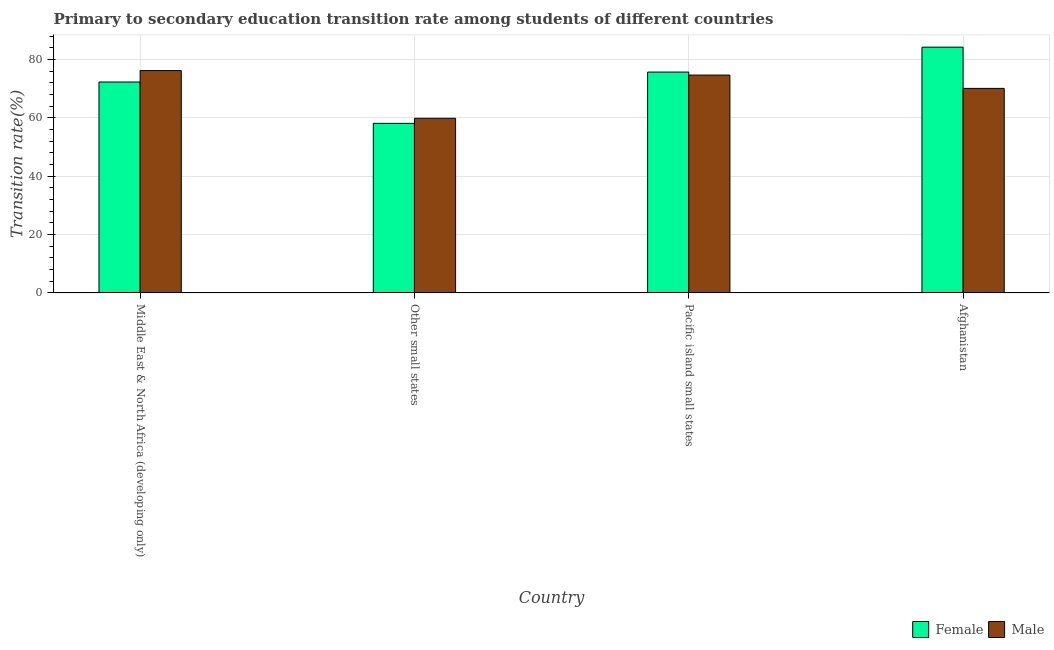How many different coloured bars are there?
Your answer should be compact. 2. How many groups of bars are there?
Your answer should be compact. 4. Are the number of bars on each tick of the X-axis equal?
Provide a succinct answer. Yes. How many bars are there on the 2nd tick from the left?
Your answer should be very brief. 2. How many bars are there on the 1st tick from the right?
Keep it short and to the point. 2. What is the label of the 2nd group of bars from the left?
Provide a short and direct response. Other small states. In how many cases, is the number of bars for a given country not equal to the number of legend labels?
Give a very brief answer. 0. What is the transition rate among female students in Afghanistan?
Offer a terse response. 84.23. Across all countries, what is the maximum transition rate among male students?
Provide a short and direct response. 76.2. Across all countries, what is the minimum transition rate among female students?
Offer a terse response. 58.12. In which country was the transition rate among male students maximum?
Offer a very short reply. Middle East & North Africa (developing only). In which country was the transition rate among male students minimum?
Give a very brief answer. Other small states. What is the total transition rate among female students in the graph?
Your response must be concise. 290.34. What is the difference between the transition rate among female students in Afghanistan and that in Pacific island small states?
Provide a succinct answer. 8.54. What is the difference between the transition rate among female students in Afghanistan and the transition rate among male students in Pacific island small states?
Your response must be concise. 9.56. What is the average transition rate among female students per country?
Keep it short and to the point. 72.58. What is the difference between the transition rate among male students and transition rate among female students in Pacific island small states?
Offer a very short reply. -1.03. In how many countries, is the transition rate among female students greater than 52 %?
Provide a short and direct response. 4. What is the ratio of the transition rate among female students in Afghanistan to that in Middle East & North Africa (developing only)?
Give a very brief answer. 1.17. What is the difference between the highest and the second highest transition rate among female students?
Keep it short and to the point. 8.54. What is the difference between the highest and the lowest transition rate among male students?
Provide a short and direct response. 16.35. What does the 1st bar from the right in Pacific island small states represents?
Ensure brevity in your answer.  Male. Are all the bars in the graph horizontal?
Your answer should be compact. No. How many countries are there in the graph?
Ensure brevity in your answer.  4. What is the difference between two consecutive major ticks on the Y-axis?
Your answer should be very brief. 20. Does the graph contain any zero values?
Give a very brief answer. No. Where does the legend appear in the graph?
Provide a short and direct response. Bottom right. How are the legend labels stacked?
Your answer should be very brief. Horizontal. What is the title of the graph?
Offer a very short reply. Primary to secondary education transition rate among students of different countries. Does "Food" appear as one of the legend labels in the graph?
Offer a terse response. No. What is the label or title of the X-axis?
Make the answer very short. Country. What is the label or title of the Y-axis?
Your answer should be compact. Transition rate(%). What is the Transition rate(%) in Female in Middle East & North Africa (developing only)?
Give a very brief answer. 72.29. What is the Transition rate(%) of Male in Middle East & North Africa (developing only)?
Offer a terse response. 76.2. What is the Transition rate(%) of Female in Other small states?
Make the answer very short. 58.12. What is the Transition rate(%) in Male in Other small states?
Give a very brief answer. 59.86. What is the Transition rate(%) of Female in Pacific island small states?
Keep it short and to the point. 75.7. What is the Transition rate(%) in Male in Pacific island small states?
Make the answer very short. 74.67. What is the Transition rate(%) in Female in Afghanistan?
Provide a short and direct response. 84.23. What is the Transition rate(%) in Male in Afghanistan?
Provide a succinct answer. 70.1. Across all countries, what is the maximum Transition rate(%) of Female?
Offer a very short reply. 84.23. Across all countries, what is the maximum Transition rate(%) in Male?
Provide a short and direct response. 76.2. Across all countries, what is the minimum Transition rate(%) in Female?
Offer a very short reply. 58.12. Across all countries, what is the minimum Transition rate(%) of Male?
Provide a short and direct response. 59.86. What is the total Transition rate(%) in Female in the graph?
Offer a terse response. 290.33. What is the total Transition rate(%) of Male in the graph?
Give a very brief answer. 280.83. What is the difference between the Transition rate(%) of Female in Middle East & North Africa (developing only) and that in Other small states?
Give a very brief answer. 14.18. What is the difference between the Transition rate(%) in Male in Middle East & North Africa (developing only) and that in Other small states?
Your response must be concise. 16.35. What is the difference between the Transition rate(%) of Female in Middle East & North Africa (developing only) and that in Pacific island small states?
Give a very brief answer. -3.41. What is the difference between the Transition rate(%) of Male in Middle East & North Africa (developing only) and that in Pacific island small states?
Make the answer very short. 1.53. What is the difference between the Transition rate(%) of Female in Middle East & North Africa (developing only) and that in Afghanistan?
Ensure brevity in your answer.  -11.94. What is the difference between the Transition rate(%) of Male in Middle East & North Africa (developing only) and that in Afghanistan?
Provide a succinct answer. 6.1. What is the difference between the Transition rate(%) of Female in Other small states and that in Pacific island small states?
Give a very brief answer. -17.58. What is the difference between the Transition rate(%) of Male in Other small states and that in Pacific island small states?
Your answer should be compact. -14.81. What is the difference between the Transition rate(%) of Female in Other small states and that in Afghanistan?
Your answer should be compact. -26.12. What is the difference between the Transition rate(%) in Male in Other small states and that in Afghanistan?
Your answer should be compact. -10.25. What is the difference between the Transition rate(%) in Female in Pacific island small states and that in Afghanistan?
Offer a very short reply. -8.54. What is the difference between the Transition rate(%) of Male in Pacific island small states and that in Afghanistan?
Ensure brevity in your answer.  4.57. What is the difference between the Transition rate(%) of Female in Middle East & North Africa (developing only) and the Transition rate(%) of Male in Other small states?
Your answer should be compact. 12.43. What is the difference between the Transition rate(%) in Female in Middle East & North Africa (developing only) and the Transition rate(%) in Male in Pacific island small states?
Keep it short and to the point. -2.38. What is the difference between the Transition rate(%) of Female in Middle East & North Africa (developing only) and the Transition rate(%) of Male in Afghanistan?
Your answer should be very brief. 2.19. What is the difference between the Transition rate(%) of Female in Other small states and the Transition rate(%) of Male in Pacific island small states?
Your response must be concise. -16.55. What is the difference between the Transition rate(%) of Female in Other small states and the Transition rate(%) of Male in Afghanistan?
Your answer should be compact. -11.99. What is the difference between the Transition rate(%) in Female in Pacific island small states and the Transition rate(%) in Male in Afghanistan?
Your answer should be compact. 5.59. What is the average Transition rate(%) of Female per country?
Your answer should be very brief. 72.58. What is the average Transition rate(%) in Male per country?
Provide a succinct answer. 70.21. What is the difference between the Transition rate(%) of Female and Transition rate(%) of Male in Middle East & North Africa (developing only)?
Make the answer very short. -3.91. What is the difference between the Transition rate(%) of Female and Transition rate(%) of Male in Other small states?
Keep it short and to the point. -1.74. What is the difference between the Transition rate(%) in Female and Transition rate(%) in Male in Pacific island small states?
Ensure brevity in your answer.  1.03. What is the difference between the Transition rate(%) in Female and Transition rate(%) in Male in Afghanistan?
Ensure brevity in your answer.  14.13. What is the ratio of the Transition rate(%) in Female in Middle East & North Africa (developing only) to that in Other small states?
Give a very brief answer. 1.24. What is the ratio of the Transition rate(%) in Male in Middle East & North Africa (developing only) to that in Other small states?
Provide a succinct answer. 1.27. What is the ratio of the Transition rate(%) of Female in Middle East & North Africa (developing only) to that in Pacific island small states?
Provide a short and direct response. 0.95. What is the ratio of the Transition rate(%) of Male in Middle East & North Africa (developing only) to that in Pacific island small states?
Offer a terse response. 1.02. What is the ratio of the Transition rate(%) of Female in Middle East & North Africa (developing only) to that in Afghanistan?
Make the answer very short. 0.86. What is the ratio of the Transition rate(%) of Male in Middle East & North Africa (developing only) to that in Afghanistan?
Provide a short and direct response. 1.09. What is the ratio of the Transition rate(%) of Female in Other small states to that in Pacific island small states?
Provide a short and direct response. 0.77. What is the ratio of the Transition rate(%) of Male in Other small states to that in Pacific island small states?
Your answer should be very brief. 0.8. What is the ratio of the Transition rate(%) in Female in Other small states to that in Afghanistan?
Your answer should be compact. 0.69. What is the ratio of the Transition rate(%) in Male in Other small states to that in Afghanistan?
Your answer should be compact. 0.85. What is the ratio of the Transition rate(%) in Female in Pacific island small states to that in Afghanistan?
Make the answer very short. 0.9. What is the ratio of the Transition rate(%) in Male in Pacific island small states to that in Afghanistan?
Your answer should be very brief. 1.07. What is the difference between the highest and the second highest Transition rate(%) of Female?
Your response must be concise. 8.54. What is the difference between the highest and the second highest Transition rate(%) of Male?
Provide a succinct answer. 1.53. What is the difference between the highest and the lowest Transition rate(%) of Female?
Give a very brief answer. 26.12. What is the difference between the highest and the lowest Transition rate(%) of Male?
Offer a very short reply. 16.35. 